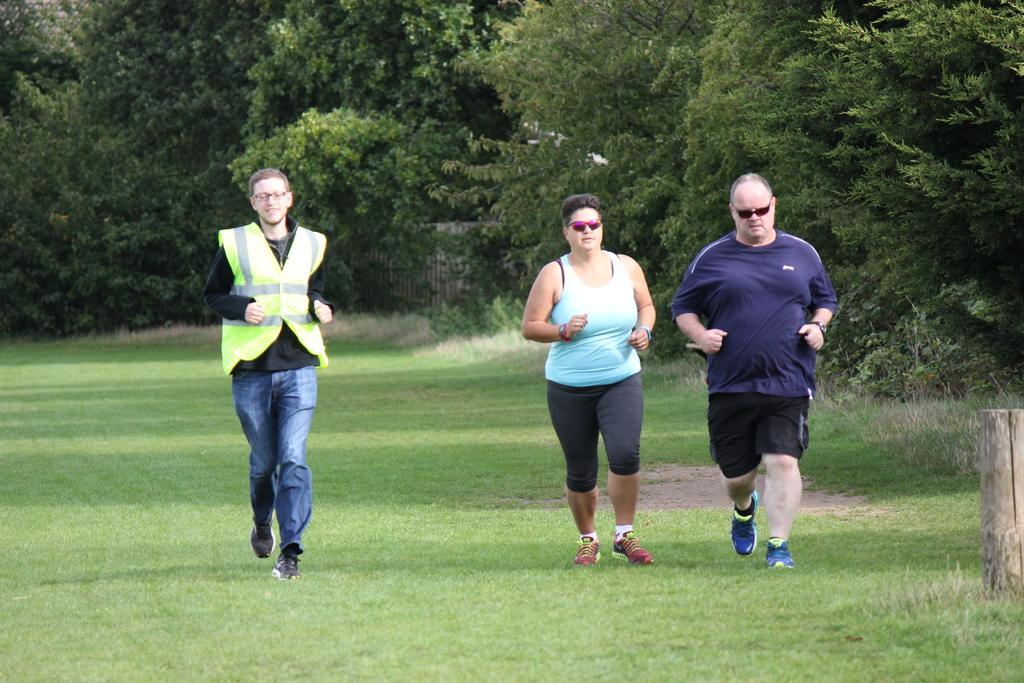Describe this image in one or two sentences. In this image there are three persons running on the ground. In the background there are trees. On the left side there is a man who is running on the ground by wearing the green jacket. On the right side there is a wooden stick. 